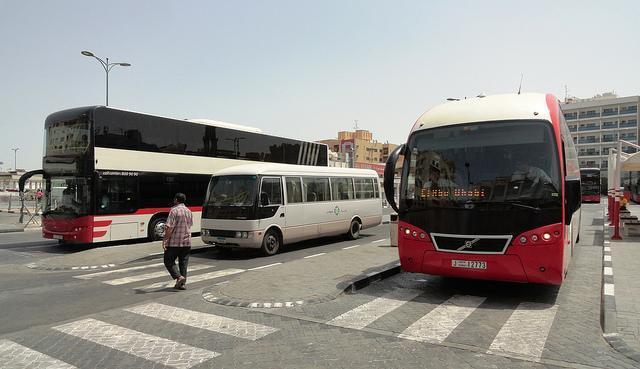How many buses are there?
Give a very brief answer. 3. 